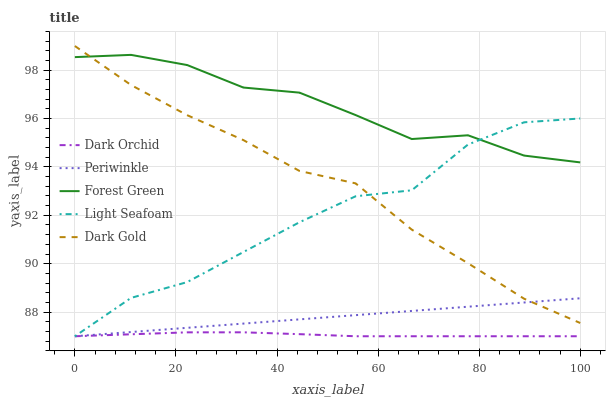Does Dark Orchid have the minimum area under the curve?
Answer yes or no. Yes. Does Forest Green have the maximum area under the curve?
Answer yes or no. Yes. Does Light Seafoam have the minimum area under the curve?
Answer yes or no. No. Does Light Seafoam have the maximum area under the curve?
Answer yes or no. No. Is Periwinkle the smoothest?
Answer yes or no. Yes. Is Light Seafoam the roughest?
Answer yes or no. Yes. Is Light Seafoam the smoothest?
Answer yes or no. No. Is Periwinkle the roughest?
Answer yes or no. No. Does Dark Gold have the lowest value?
Answer yes or no. No. Does Light Seafoam have the highest value?
Answer yes or no. No. Is Dark Orchid less than Dark Gold?
Answer yes or no. Yes. Is Forest Green greater than Dark Orchid?
Answer yes or no. Yes. Does Dark Orchid intersect Dark Gold?
Answer yes or no. No. 